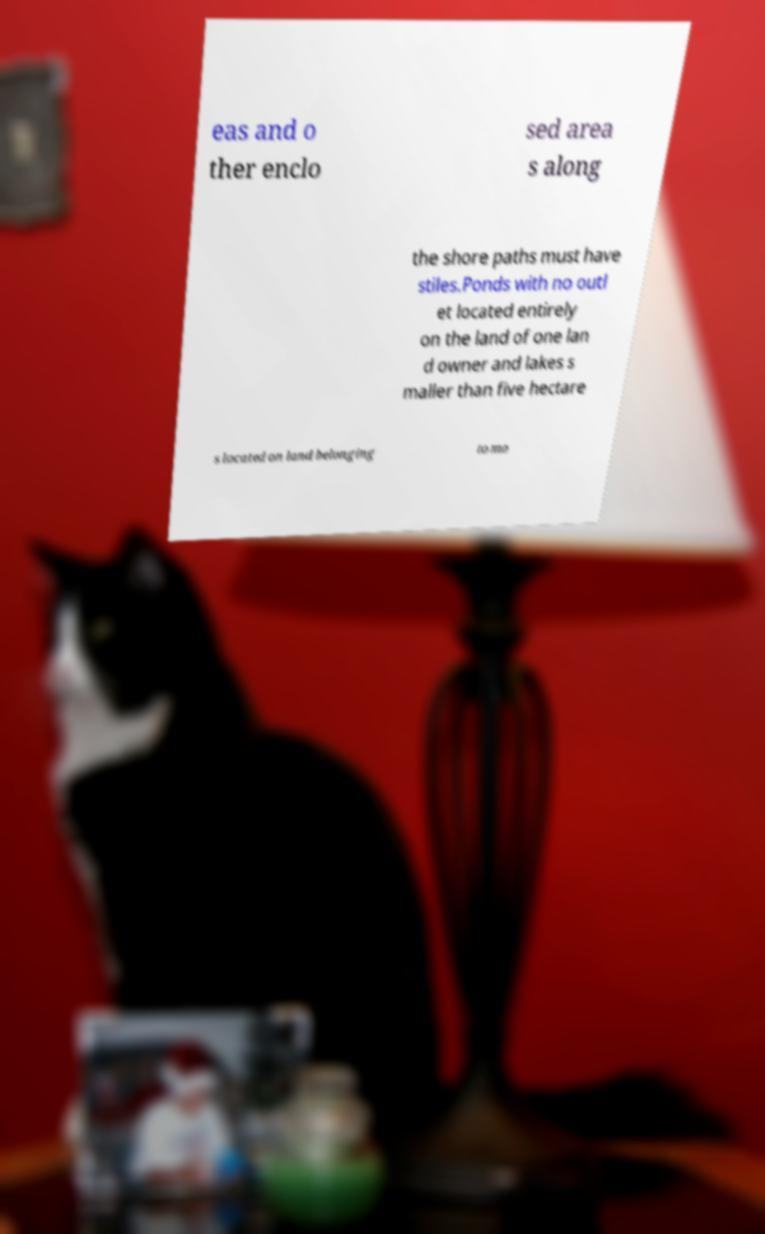Could you extract and type out the text from this image? eas and o ther enclo sed area s along the shore paths must have stiles.Ponds with no outl et located entirely on the land of one lan d owner and lakes s maller than five hectare s located on land belonging to mo 